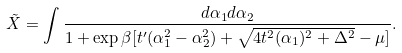<formula> <loc_0><loc_0><loc_500><loc_500>\tilde { X } = \int \frac { d \alpha _ { 1 } d \alpha _ { 2 } } { 1 + \exp { \beta [ t ^ { \prime } ( \alpha _ { 1 } ^ { 2 } - \alpha _ { 2 } ^ { 2 } ) + \sqrt { 4 t ^ { 2 } ( \alpha _ { 1 } ) ^ { 2 } + \Delta ^ { 2 } } - \mu ] } } .</formula> 